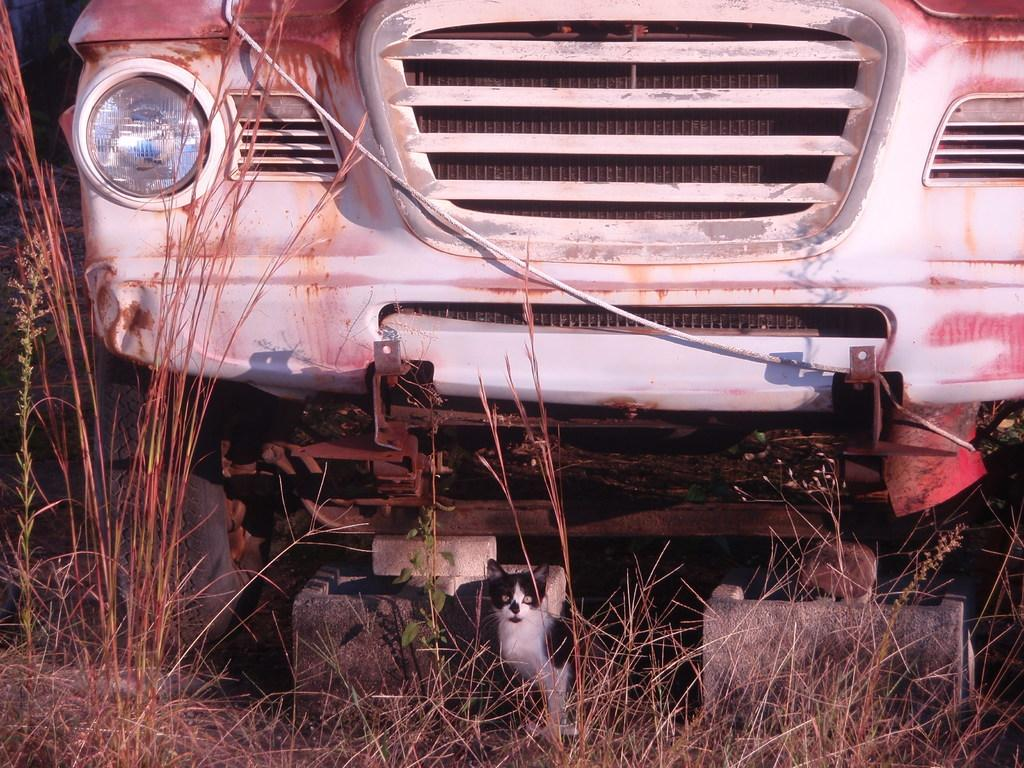What type of vehicle is in the image? There is an old car in the image. What else can be seen in the image besides the car? There are stones, grass, and other plants in the image. Can you describe the natural elements in the image? The image features grass and other plants, as well as stones. What type of punishment is being carried out in the image? There is no indication of punishment in the image; it features an old car and natural elements. 